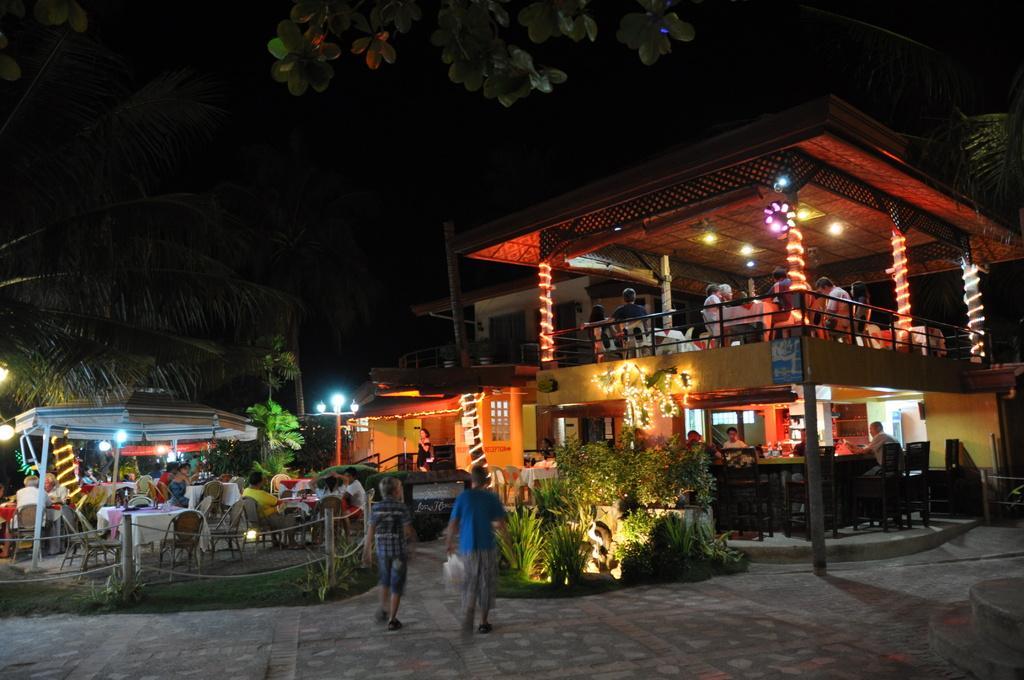In one or two sentences, can you explain what this image depicts? This picture shows few buildings and trees and we see lighting and few pole lights and we see tables and chairs few people seated and few are standing. we see couple of them walking and we see plants. 